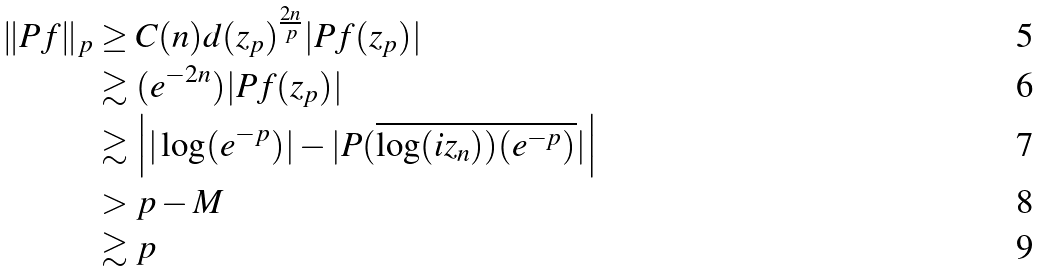<formula> <loc_0><loc_0><loc_500><loc_500>\| P f \| _ { p } & \geq C ( n ) d ( z _ { p } ) ^ { \frac { 2 n } { p } } | P f ( z _ { p } ) | \\ & \gtrsim ( e ^ { - 2 n } ) | P f ( z _ { p } ) | \\ & \gtrsim \left | | \log ( e ^ { - p } ) | - | P ( \overline { \log ( i z _ { n } ) ) ( e ^ { - p } ) } | \right | \\ & > p - M \\ & \gtrsim p</formula> 